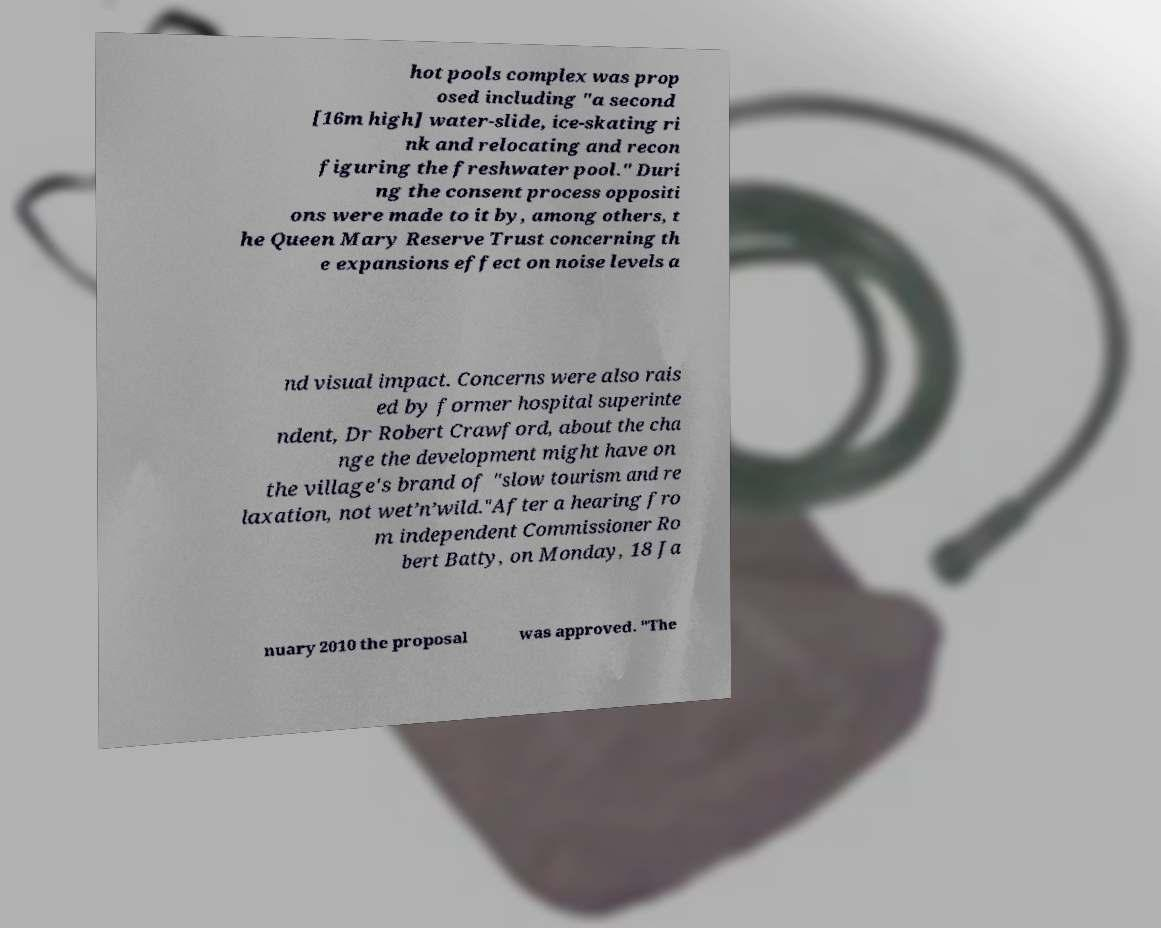What messages or text are displayed in this image? I need them in a readable, typed format. hot pools complex was prop osed including "a second [16m high] water-slide, ice-skating ri nk and relocating and recon figuring the freshwater pool." Duri ng the consent process oppositi ons were made to it by, among others, t he Queen Mary Reserve Trust concerning th e expansions effect on noise levels a nd visual impact. Concerns were also rais ed by former hospital superinte ndent, Dr Robert Crawford, about the cha nge the development might have on the village's brand of "slow tourism and re laxation, not wet’n’wild."After a hearing fro m independent Commissioner Ro bert Batty, on Monday, 18 Ja nuary 2010 the proposal was approved. "The 